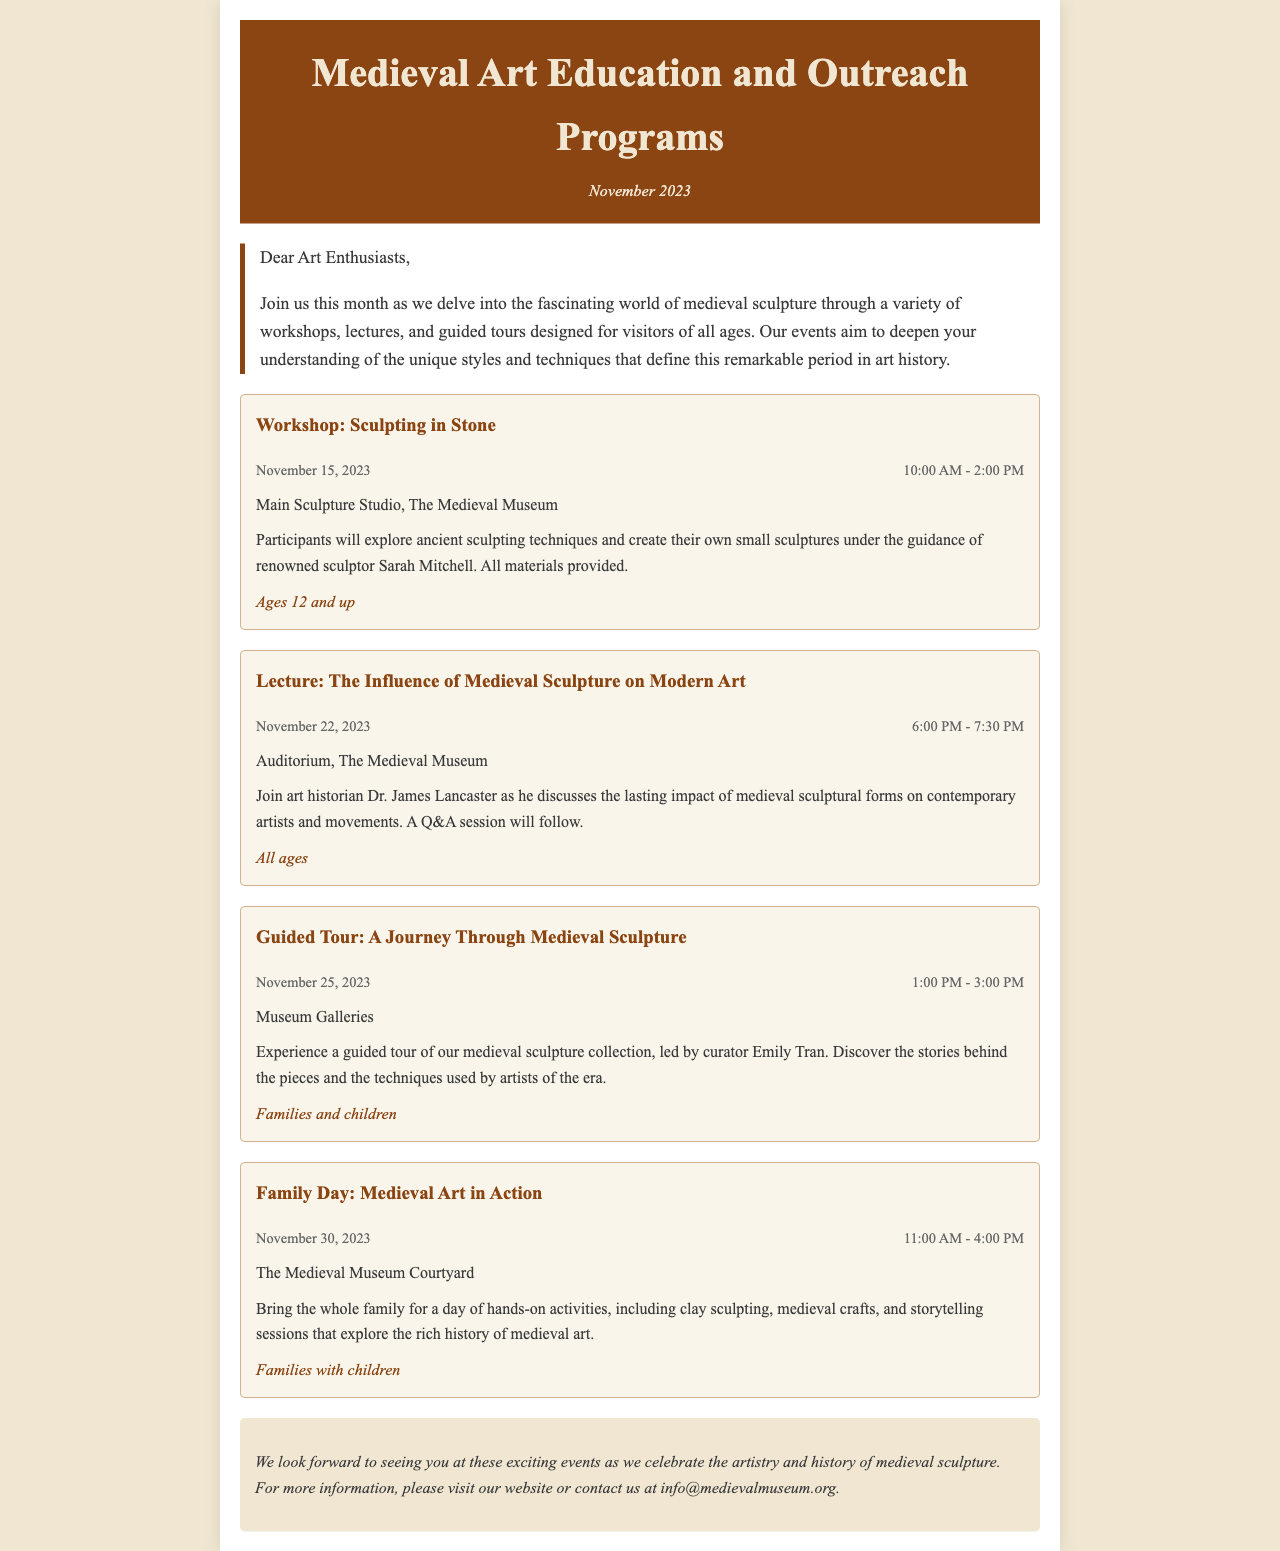What is the title of the newsletter? The title of the newsletter is presented prominently at the top of the document.
Answer: Medieval Art Education and Outreach Programs What is the date of the first event listed? The first event is a workshop scheduled for a specific date displayed in the document.
Answer: November 15, 2023 Who is leading the guided tour? The document states the name of the curator leading the guided tour in the description of the event.
Answer: Emily Tran What is the target audience for the Family Day event? The event description specifies the intended audience for the Family Day activity.
Answer: Families with children What time does the lecture start? The lecture event details include the starting time, which is noted in the schedule section.
Answer: 6:00 PM What type of activities will be available on Family Day? The event description lists multiple hands-on activities available for participants.
Answer: Clay sculpting, medieval crafts, storytelling What is the main focus of the lecture on November 22? The description outlines the main theme of the lecture presented by the speaker.
Answer: The Influence of Medieval Sculpture on Modern Art How long is the guided tour? The event details mention the duration of the guided tour explicitly in the schedule.
Answer: 2 hours 